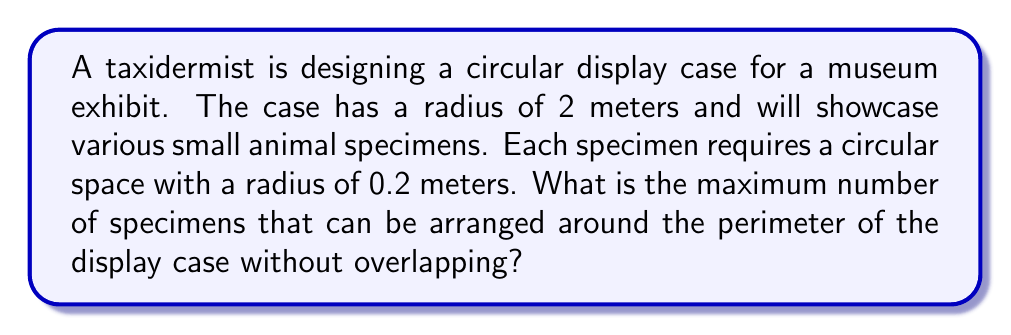Show me your answer to this math problem. To solve this problem, we need to follow these steps:

1) First, let's calculate the circumference of the display case:
   $$C = 2\pi r$$
   where $r$ is the radius of the display case.
   $$C = 2\pi(2) = 4\pi \approx 12.57\text{ meters}$$

2) Now, we need to determine how much space each specimen occupies along the circumference. Each specimen is represented by a circle with a radius of 0.2 meters. The arc length it occupies on the larger circle is equal to its diameter:
   $$\text{Space per specimen} = 2(0.2) = 0.4\text{ meters}$$

3) To find the maximum number of specimens, we divide the circumference by the space each specimen occupies:
   $$\text{Number of specimens} = \frac{\text{Circumference}}{\text{Space per specimen}}$$

4) Substituting the values:
   $$\text{Number of specimens} = \frac{4\pi}{0.4} = 10\pi \approx 31.42$$

5) Since we can't have a fractional number of specimens, we round down to the nearest whole number.

[asy]
unitsize(50);
draw(circle((0,0),2));
for(int i=0; i<31; ++i) {
  real angle = 2*pi*i/31;
  draw(circle((2*cos(angle),2*sin(angle)),0.2));
}
[/asy]
Answer: The maximum number of specimens that can be arranged around the perimeter of the display case without overlapping is 31. 